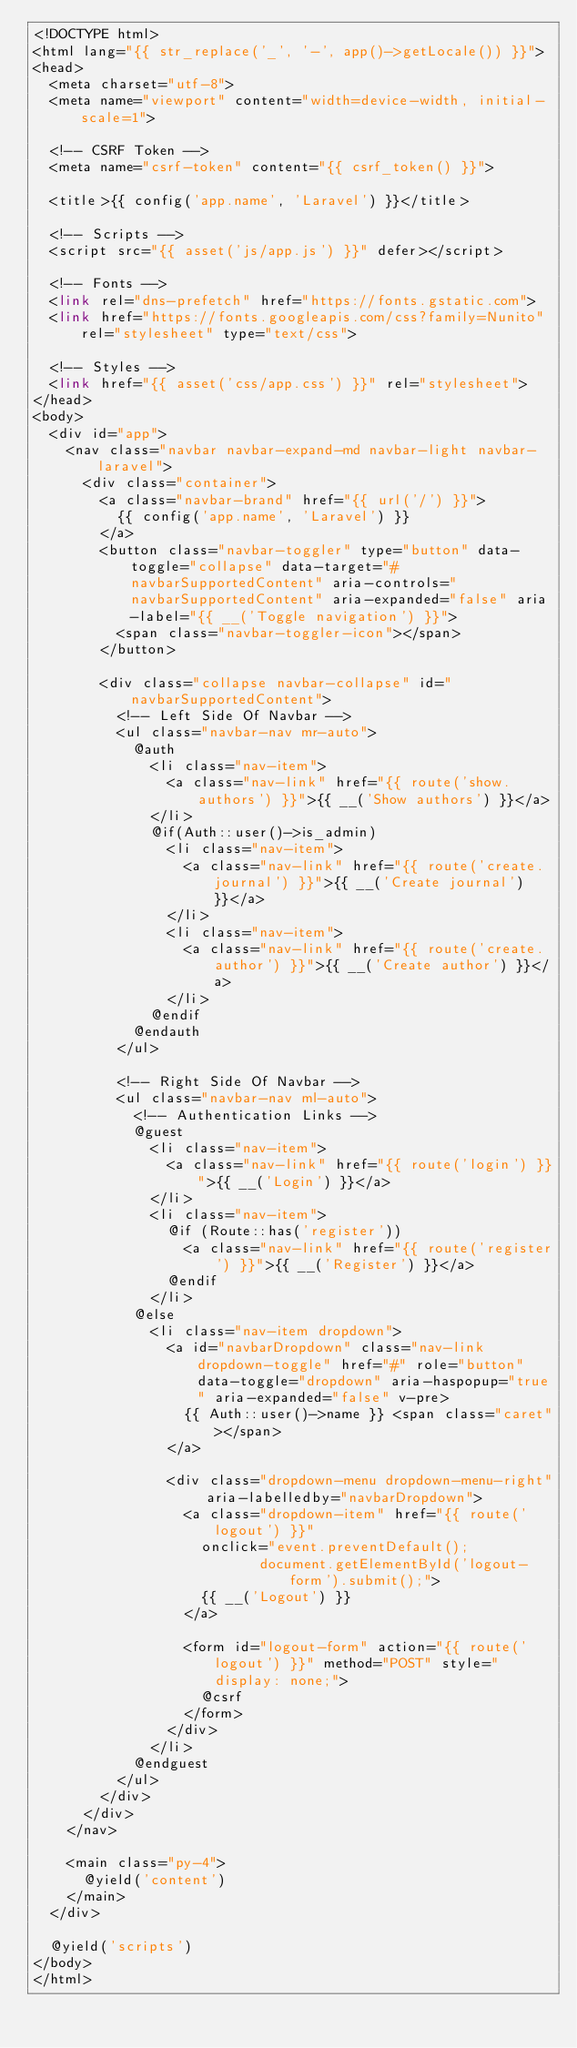<code> <loc_0><loc_0><loc_500><loc_500><_PHP_><!DOCTYPE html>
<html lang="{{ str_replace('_', '-', app()->getLocale()) }}">
<head>
	<meta charset="utf-8">
	<meta name="viewport" content="width=device-width, initial-scale=1">

	<!-- CSRF Token -->
	<meta name="csrf-token" content="{{ csrf_token() }}">

	<title>{{ config('app.name', 'Laravel') }}</title>

	<!-- Scripts -->
	<script src="{{ asset('js/app.js') }}" defer></script>

	<!-- Fonts -->
	<link rel="dns-prefetch" href="https://fonts.gstatic.com">
	<link href="https://fonts.googleapis.com/css?family=Nunito" rel="stylesheet" type="text/css">

	<!-- Styles -->
	<link href="{{ asset('css/app.css') }}" rel="stylesheet">
</head>
<body>
	<div id="app">
		<nav class="navbar navbar-expand-md navbar-light navbar-laravel">
			<div class="container">
				<a class="navbar-brand" href="{{ url('/') }}">
					{{ config('app.name', 'Laravel') }}
				</a>
				<button class="navbar-toggler" type="button" data-toggle="collapse" data-target="#navbarSupportedContent" aria-controls="navbarSupportedContent" aria-expanded="false" aria-label="{{ __('Toggle navigation') }}">
					<span class="navbar-toggler-icon"></span>
				</button>

				<div class="collapse navbar-collapse" id="navbarSupportedContent">
					<!-- Left Side Of Navbar -->
					<ul class="navbar-nav mr-auto">
						@auth
							<li class="nav-item">
								<a class="nav-link" href="{{ route('show.authors') }}">{{ __('Show authors') }}</a>
							</li>
							@if(Auth::user()->is_admin)
								<li class="nav-item">
									<a class="nav-link" href="{{ route('create.journal') }}">{{ __('Create journal') }}</a>
								</li>
								<li class="nav-item">
									<a class="nav-link" href="{{ route('create.author') }}">{{ __('Create author') }}</a>
								</li>
							@endif
						@endauth
					</ul>

					<!-- Right Side Of Navbar -->
					<ul class="navbar-nav ml-auto">
						<!-- Authentication Links -->
						@guest
							<li class="nav-item">
								<a class="nav-link" href="{{ route('login') }}">{{ __('Login') }}</a>
							</li>
							<li class="nav-item">
								@if (Route::has('register'))
									<a class="nav-link" href="{{ route('register') }}">{{ __('Register') }}</a>
								@endif
							</li>
						@else
							<li class="nav-item dropdown">
								<a id="navbarDropdown" class="nav-link dropdown-toggle" href="#" role="button" data-toggle="dropdown" aria-haspopup="true" aria-expanded="false" v-pre>
									{{ Auth::user()->name }} <span class="caret"></span>
								</a>

								<div class="dropdown-menu dropdown-menu-right" aria-labelledby="navbarDropdown">
									<a class="dropdown-item" href="{{ route('logout') }}"
										onclick="event.preventDefault();
													 document.getElementById('logout-form').submit();">
										{{ __('Logout') }}
									</a>

									<form id="logout-form" action="{{ route('logout') }}" method="POST" style="display: none;">
										@csrf
									</form>
								</div>
							</li>
						@endguest
					</ul>
				</div>
			</div>
		</nav>

		<main class="py-4">
			@yield('content')
		</main>
	</div>

	@yield('scripts')
</body>
</html>
</code> 